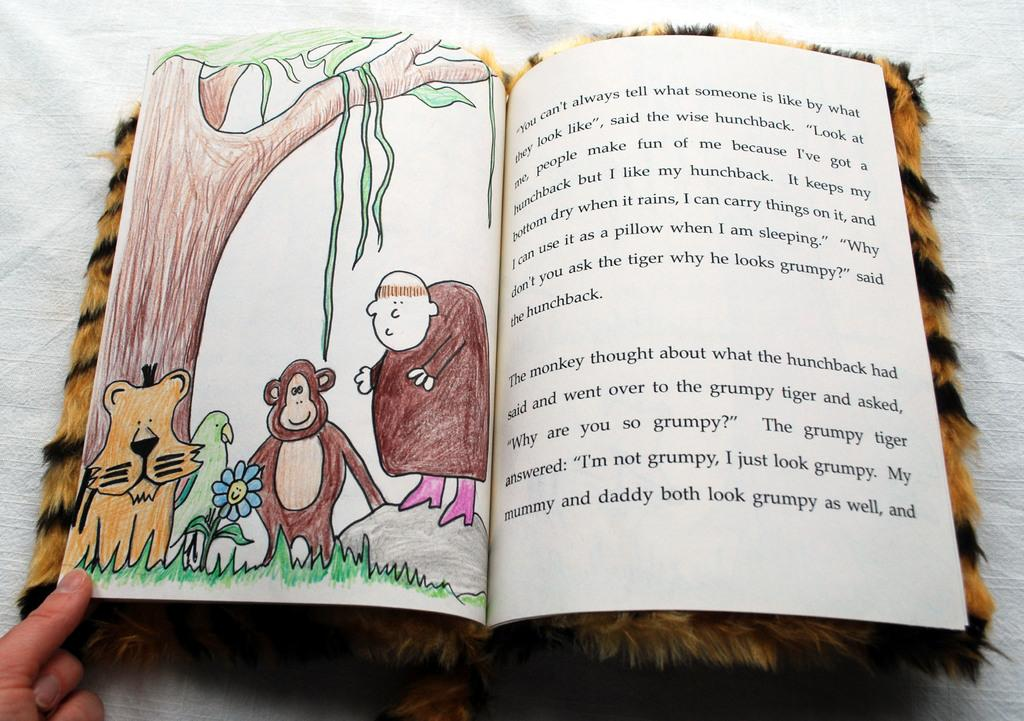Provide a one-sentence caption for the provided image. The book has a grumpy tiger in the story. 